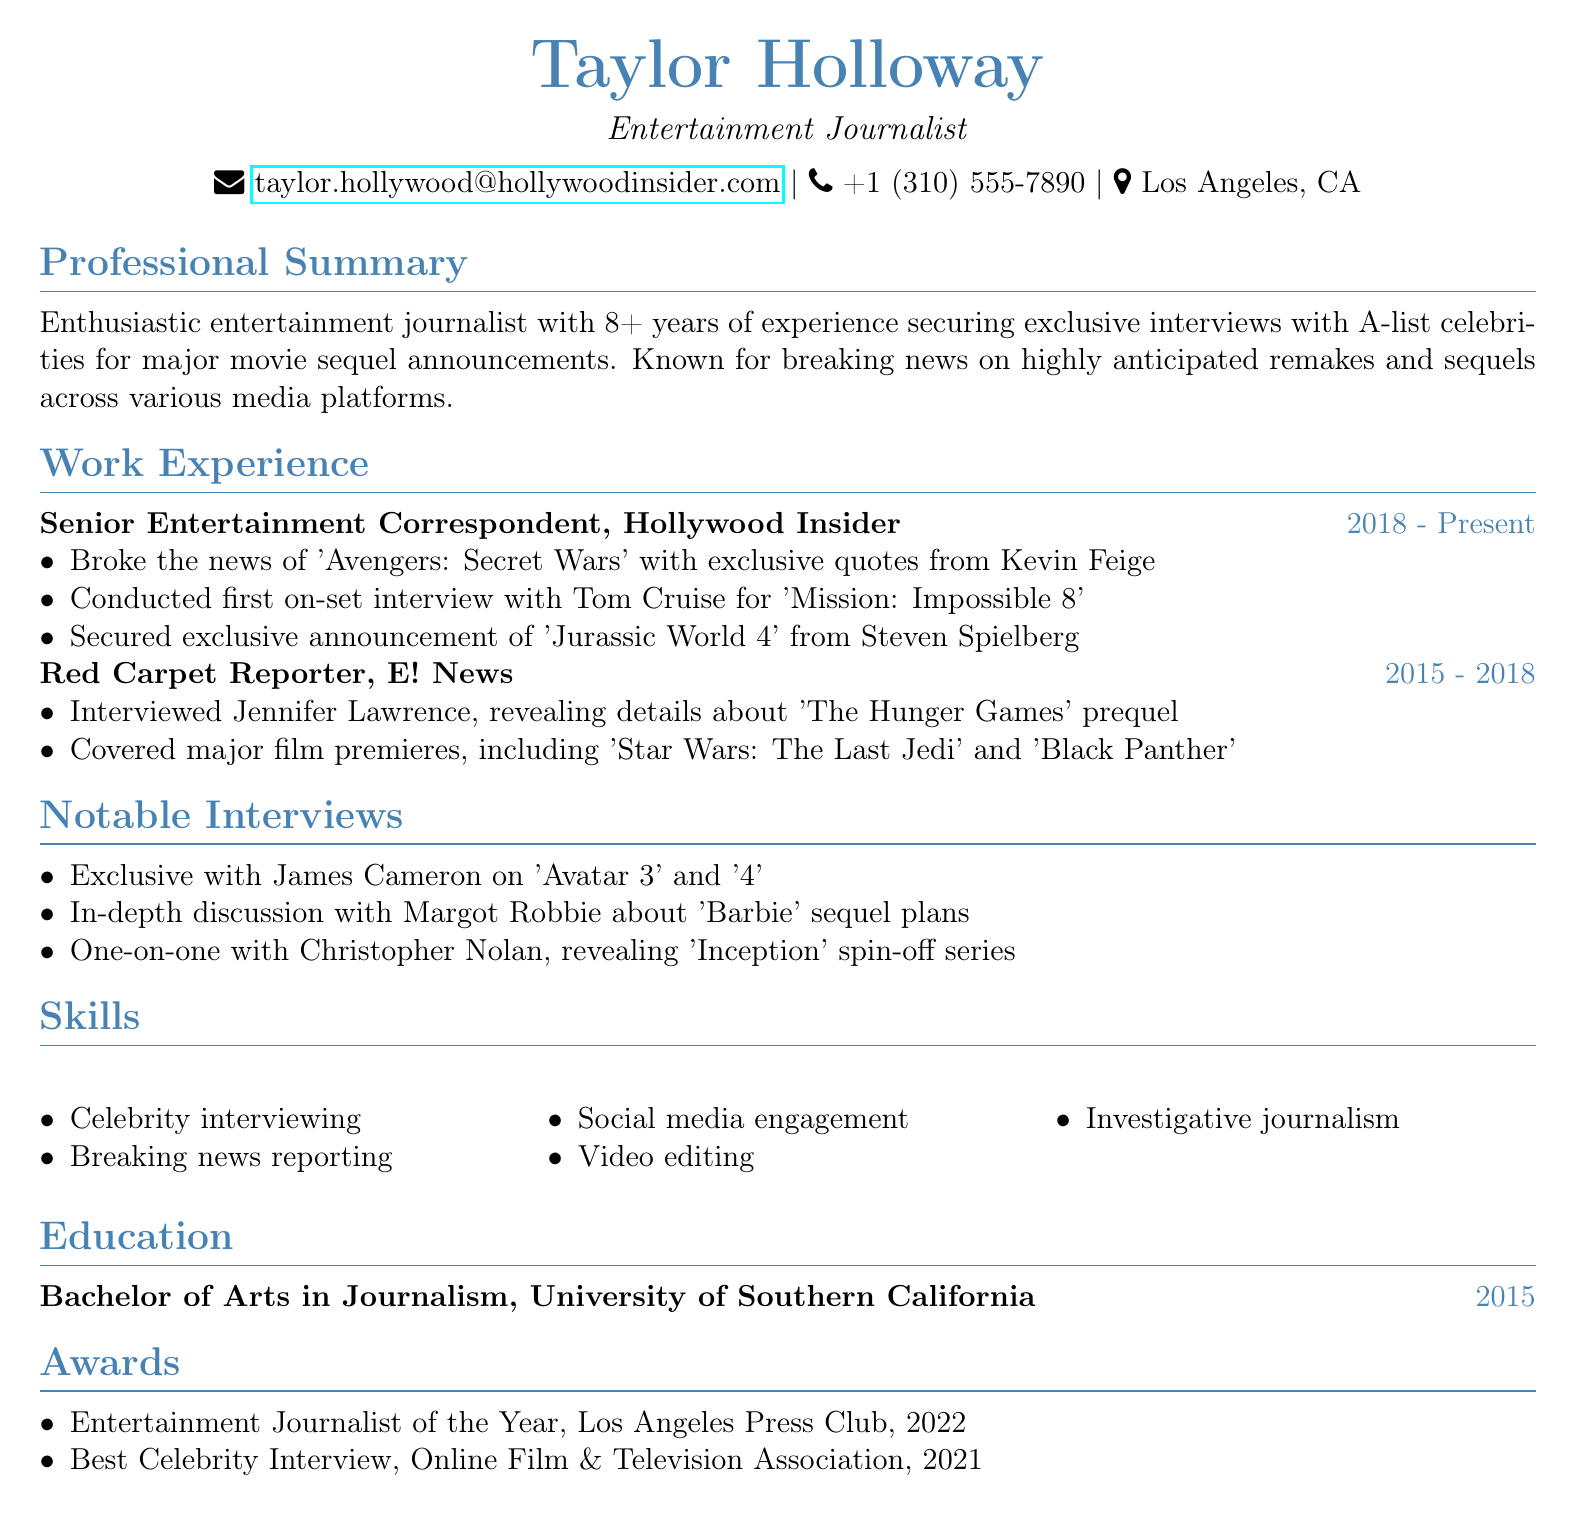What is the name of the journalist? The name of the journalist is listed at the top of the document.
Answer: Taylor Holloway What is the title of the current position? The title is found in the work experience section of the document.
Answer: Senior Entertainment Correspondent In what year did Taylor Holloway graduate? The graduation year is mentioned in the education section of the document.
Answer: 2015 What notable interview was conducted with Steven Spielberg? The interview is highlighted in the work experience section.
Answer: Jurassic World 4 How many years of experience does Taylor Holloway have? The total years of experience is stated in the professional summary.
Answer: 8+ What award did Taylor Holloway receive in 2022? The awards section lists recognitions received by the journalist.
Answer: Entertainment Journalist of the Year Which company did Taylor work for before Hollywood Insider? This information can be found in the work experience section of the document.
Answer: E! News Who did Taylor Holloway interview regarding 'Barbie' sequel plans? The notable interviews section specifies this detail.
Answer: Margot Robbie What skills are listed in the CV? The skills section includes various abilities relevant to the profession.
Answer: Celebrity interviewing, Breaking news reporting, Social media engagement, Video editing, Investigative journalism 